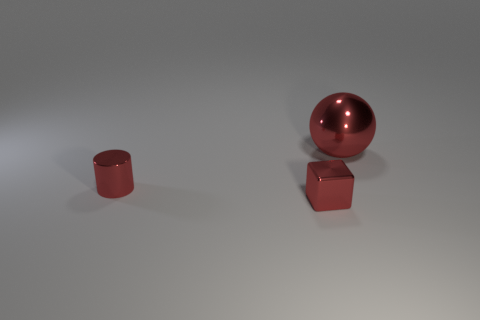Could you tell me about the lighting of the scene? The lighting in the scene is diffuse, creating soft shadows on the ground beneath each object. This indicates an evenly spread light source, likely from above, and there are no harsh shadows or highlights, which suggests an ambient or studio-lighting setup. 